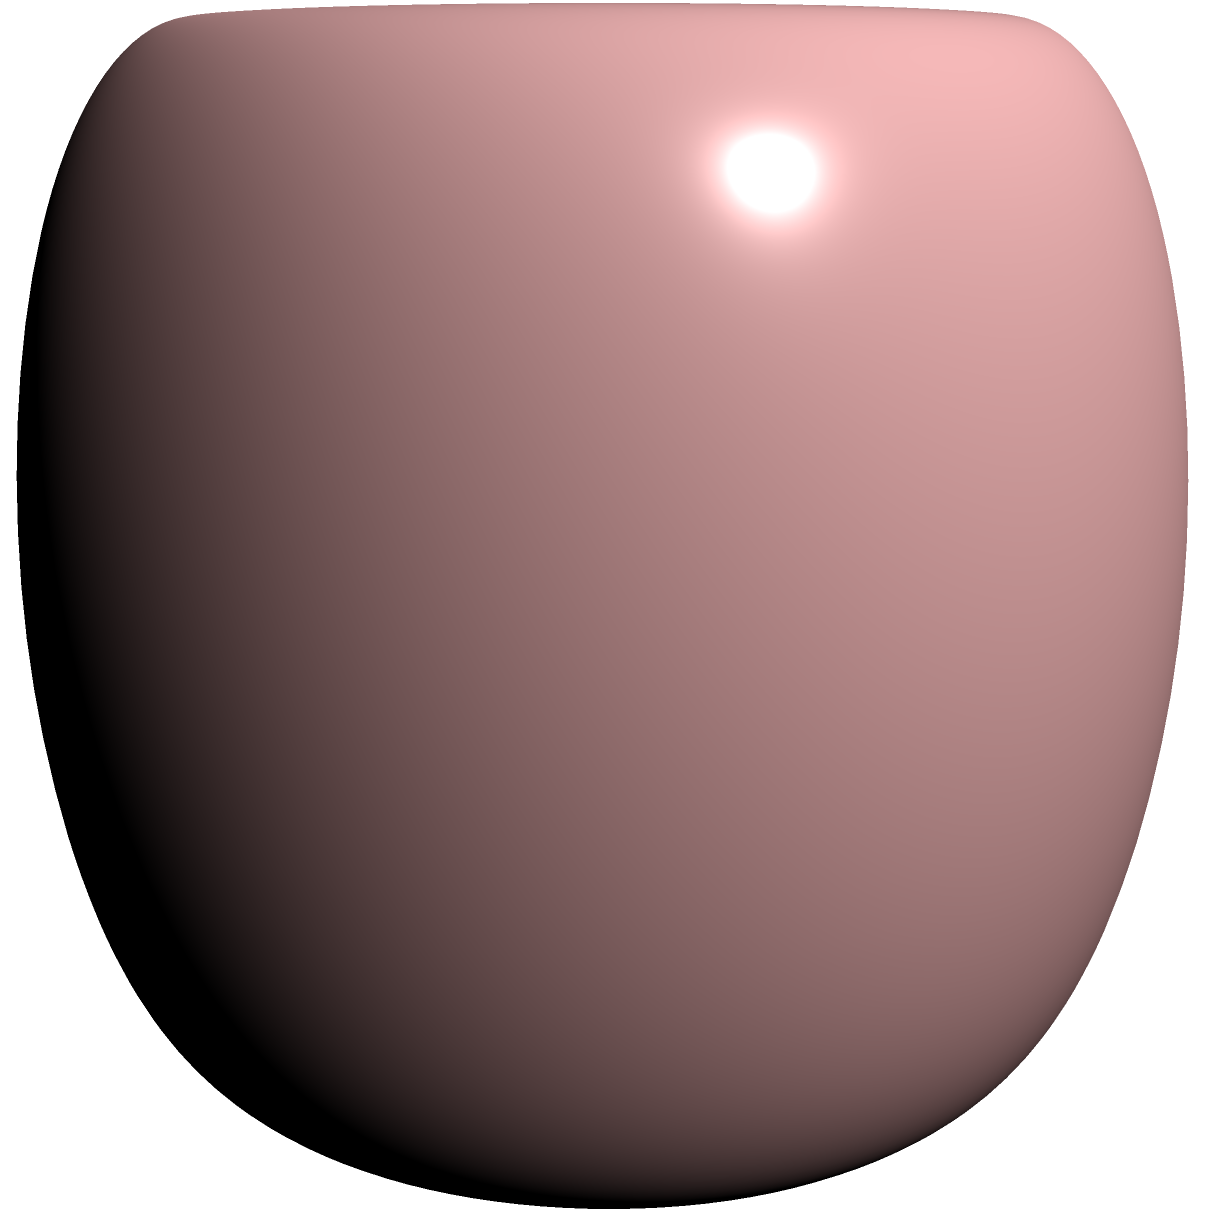As a human rights activist, you're organizing a global campaign that requires understanding different cultural perspectives. Consider the sphere and torus shown in the image as representations of different worldviews. Which surface has a constant positive Gaussian curvature, and how does this relate to the consistency of cultural perspectives across the globe? To answer this question, let's break it down step-by-step:

1. Gaussian curvature is a measure of a surface's intrinsic curvature at each point.

2. For a sphere:
   - The Gaussian curvature is constant and positive at every point.
   - It's given by the formula $K = \frac{1}{R^2}$, where $R$ is the radius of the sphere.

3. For a torus:
   - The Gaussian curvature varies depending on the location on the surface.
   - On the outer part of the torus, the curvature is positive.
   - On the inner part, the curvature is negative.
   - At the top and bottom circles (where it transitions from positive to negative), the curvature is zero.

4. The sphere has a constant positive Gaussian curvature.

5. Relating to cultural perspectives:
   - The sphere's constant curvature could represent a more uniform or consistent worldview across all points (cultures).
   - The torus's varying curvature could represent the diversity and complexity of cultural perspectives, with some areas of agreement (positive curvature) and some areas of conflict (negative curvature).

6. As a human rights activist, understanding these differences is crucial:
   - The spherical model suggests universal principles that apply equally everywhere.
   - The toroidal model suggests a more nuanced approach, acknowledging both commonalities and differences across cultures.
Answer: The sphere has constant positive Gaussian curvature, representing a uniform global perspective, while the torus's varying curvature reflects diverse cultural viewpoints. 